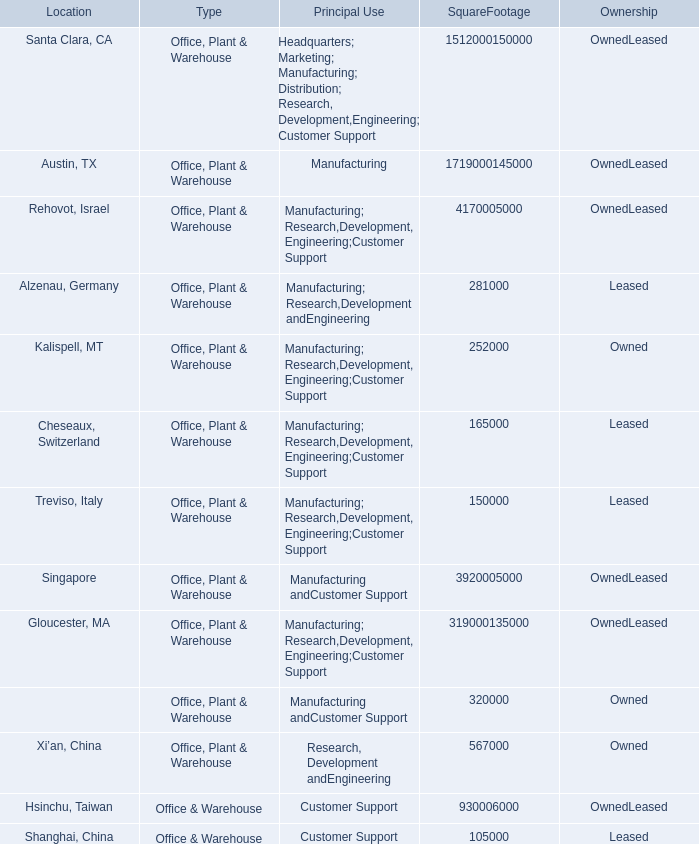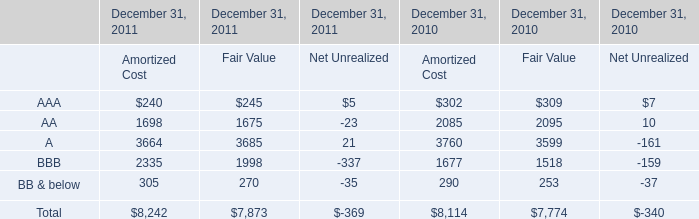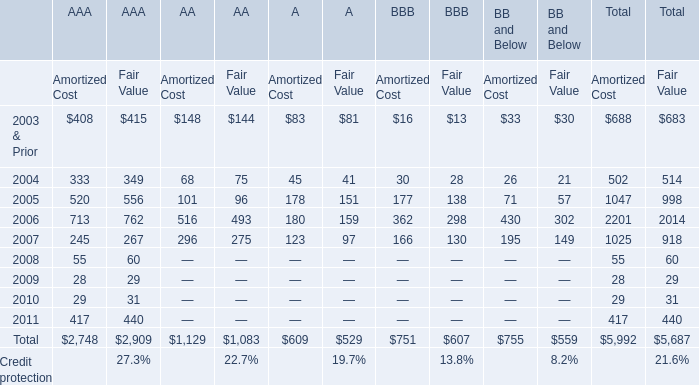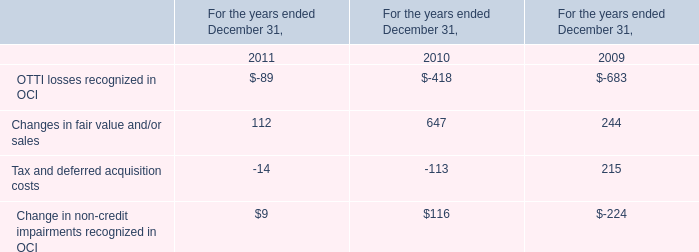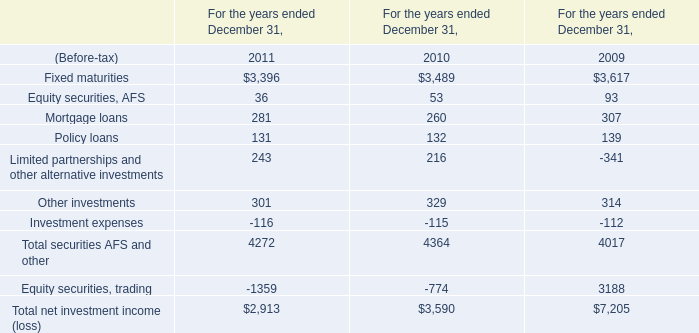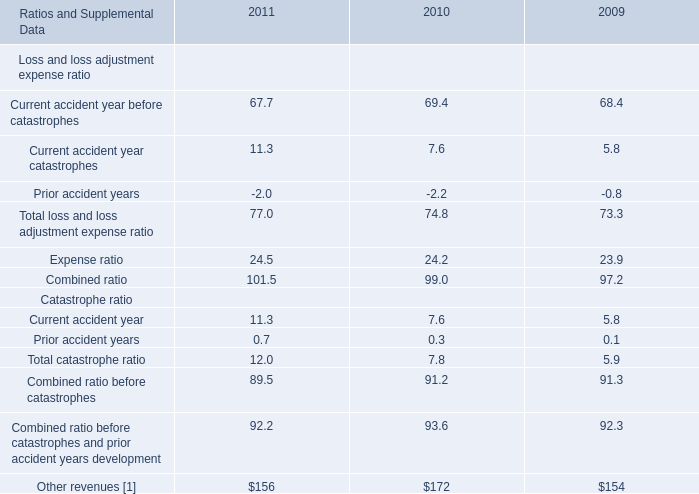In the year with largest amount of Amortized Cost of A, what's the increasing rate of Fair Value of A? 
Computations: ((97 - 159) / 159)
Answer: -0.38994. 